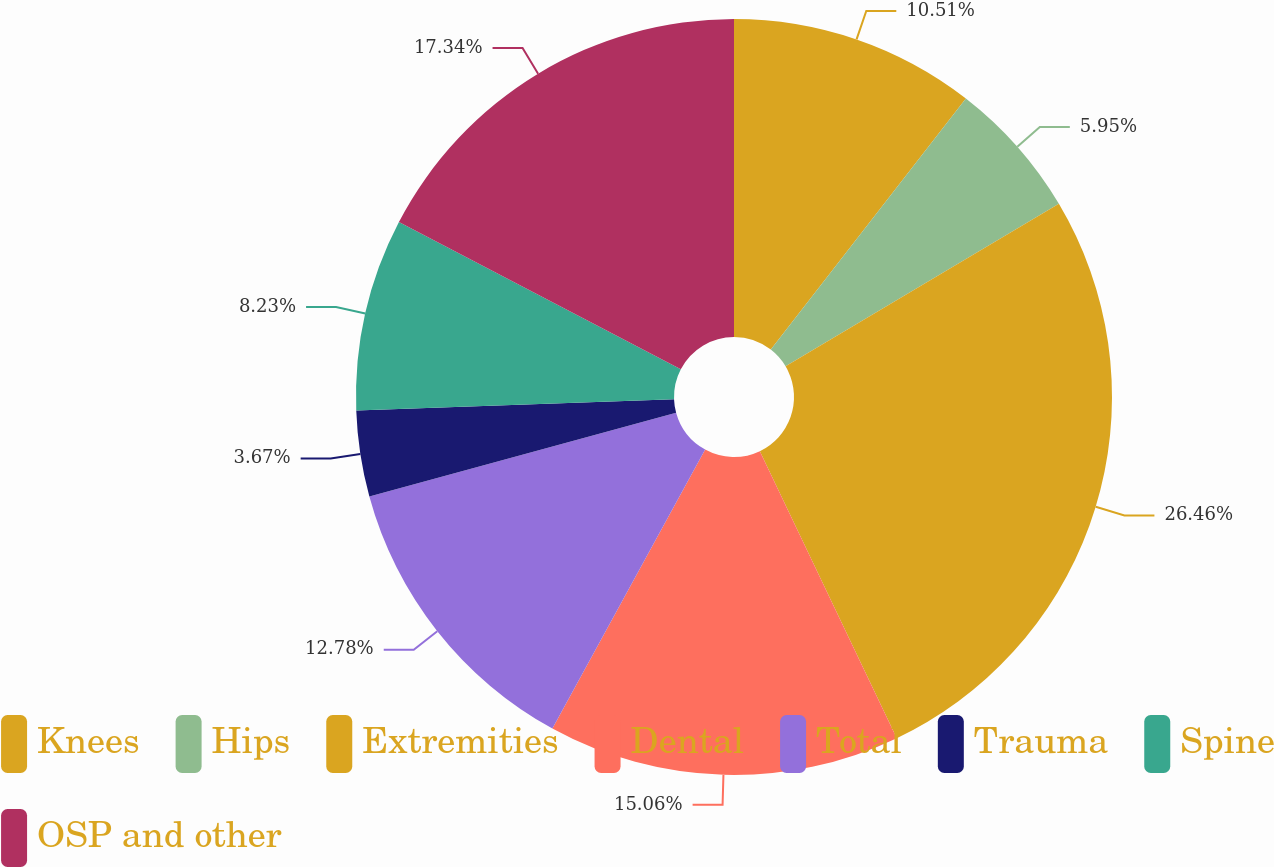Convert chart to OTSL. <chart><loc_0><loc_0><loc_500><loc_500><pie_chart><fcel>Knees<fcel>Hips<fcel>Extremities<fcel>Dental<fcel>Total<fcel>Trauma<fcel>Spine<fcel>OSP and other<nl><fcel>10.51%<fcel>5.95%<fcel>26.45%<fcel>15.06%<fcel>12.78%<fcel>3.67%<fcel>8.23%<fcel>17.34%<nl></chart> 